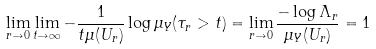<formula> <loc_0><loc_0><loc_500><loc_500>\lim _ { r \to 0 } \lim _ { t \to \infty } - \frac { 1 } { t \mu ( U _ { r } ) } \log \mu _ { Y } ( \tau _ { r } > t ) = \lim _ { r \to 0 } \frac { - \log \Lambda _ { r } } { \mu _ { Y } ( U _ { r } ) } = 1</formula> 